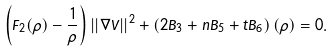<formula> <loc_0><loc_0><loc_500><loc_500>\left ( F _ { 2 } ( \rho ) - \frac { 1 } { \rho } \right ) | | \nabla V | | ^ { 2 } + \left ( 2 B _ { 3 } + n B _ { 5 } + t B _ { 6 } \right ) ( \rho ) = 0 .</formula> 